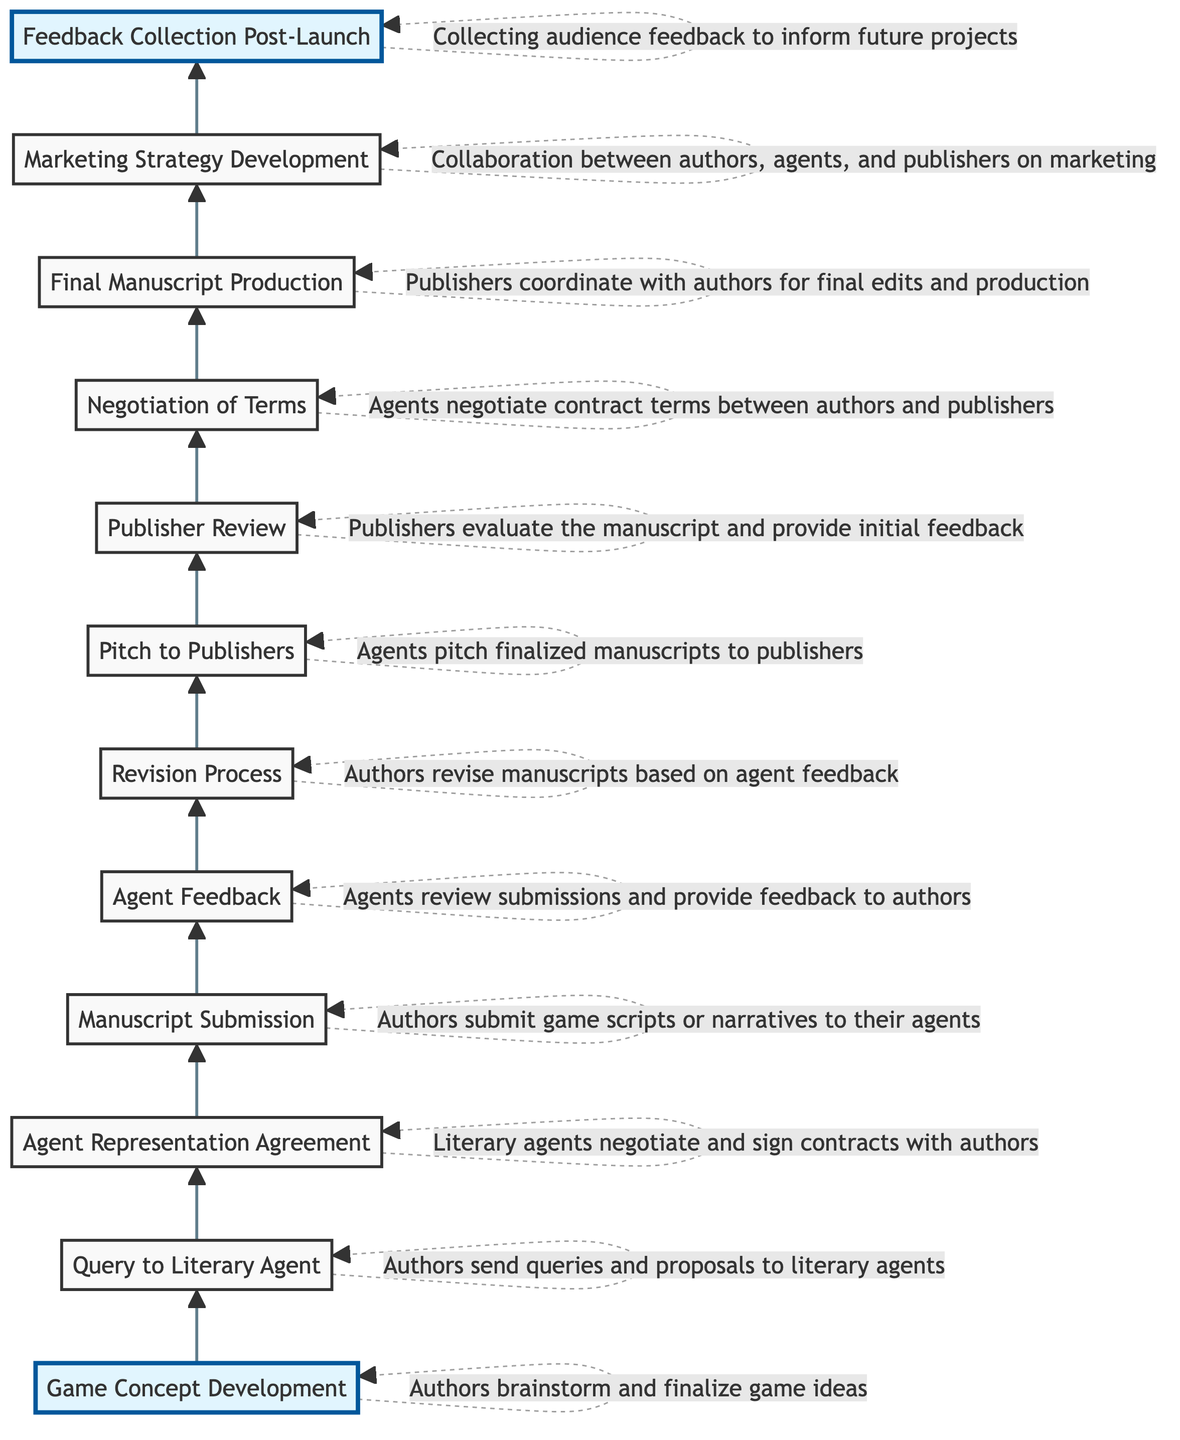What is the first step in the communication flow? The first step in the flow is "Game Concept Development," where authors brainstorm and finalize game ideas before taking any other actions.
Answer: Game Concept Development How many main steps are there in the flow of communication? By counting the nodes in the diagram, there are a total of 12 main steps involved in the flow of communication and feedback.
Answer: 12 What does the "Revision Process" entail? The "Revision Process" involves authors revising their manuscripts based on the feedback provided by the agents, ensuring that improvements are made before further submission.
Answer: Authors revise manuscripts based on agent feedback Which node follows "Agent Feedback"? After "Agent Feedback," the next node in the sequence is "Revision Process," indicating that agents provide feedback prior to the authors making necessary revisions.
Answer: Revision Process What is the final step in the communication flow? The final step in the flow is "Feedback Collection Post-Launch," where audience feedback is collected to inform future projects after the game has been launched.
Answer: Feedback Collection Post-Launch How does the "Pitch to Publishers" action take place? The "Pitch to Publishers" occurs after the "Revision Process," signaling that agents will present finalized manuscripts to the publishers for consideration after authors have revised them.
Answer: Agents pitch finalized manuscripts to publishers Which two stages involve feedback? The "Agent Feedback" and "Publisher Review" stages both involve the collection and evaluation of feedback, with agents reviewing submissions and publishers evaluating manuscripts respectively.
Answer: Agent Feedback, Publisher Review How do authors and agents collaborate on marketing? The "Marketing Strategy Development" stage highlights the collaboration among authors, agents, and publishers to create a cohesive marketing strategy for the game.
Answer: Collaboration between authors, agents, and publishers on marketing 